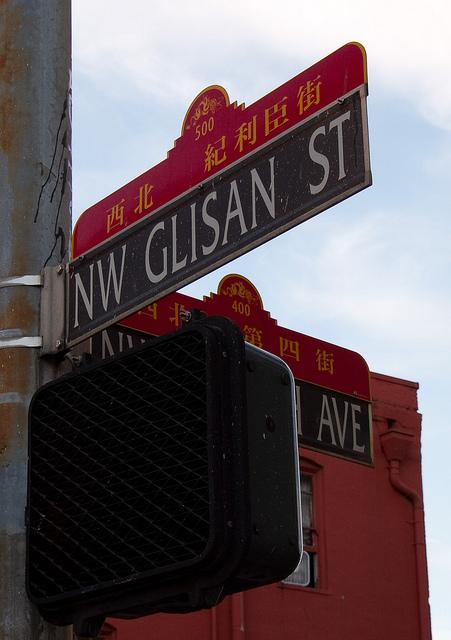Is this a street in the US?
Answer briefly. No. Is anyone standing under the sign?
Be succinct. No. Is this a newly painted sign?
Concise answer only. Yes. What street is being displayed?
Answer briefly. Nw glisan st. What city is this located?
Write a very short answer. China. Is the entire street name shown?
Keep it brief. Yes. 